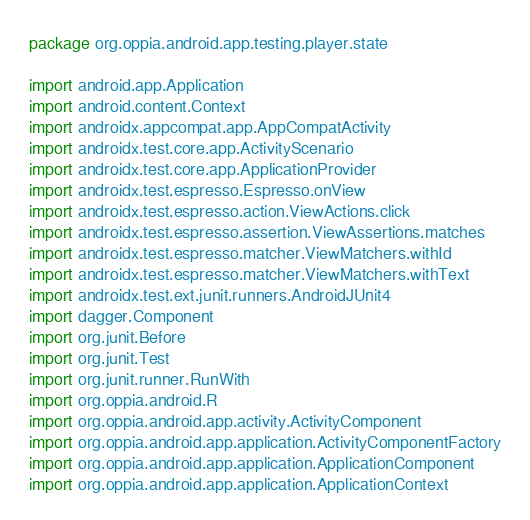<code> <loc_0><loc_0><loc_500><loc_500><_Kotlin_>package org.oppia.android.app.testing.player.state

import android.app.Application
import android.content.Context
import androidx.appcompat.app.AppCompatActivity
import androidx.test.core.app.ActivityScenario
import androidx.test.core.app.ApplicationProvider
import androidx.test.espresso.Espresso.onView
import androidx.test.espresso.action.ViewActions.click
import androidx.test.espresso.assertion.ViewAssertions.matches
import androidx.test.espresso.matcher.ViewMatchers.withId
import androidx.test.espresso.matcher.ViewMatchers.withText
import androidx.test.ext.junit.runners.AndroidJUnit4
import dagger.Component
import org.junit.Before
import org.junit.Test
import org.junit.runner.RunWith
import org.oppia.android.R
import org.oppia.android.app.activity.ActivityComponent
import org.oppia.android.app.application.ActivityComponentFactory
import org.oppia.android.app.application.ApplicationComponent
import org.oppia.android.app.application.ApplicationContext</code> 